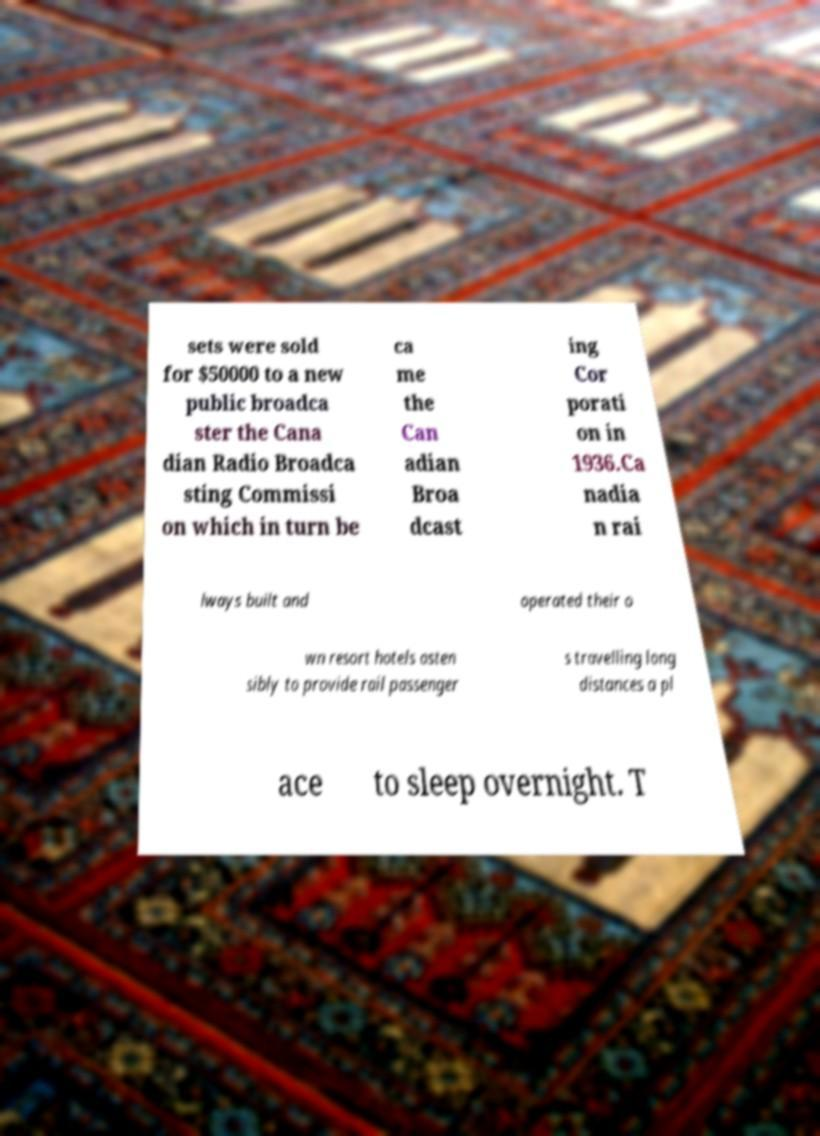Could you assist in decoding the text presented in this image and type it out clearly? sets were sold for $50000 to a new public broadca ster the Cana dian Radio Broadca sting Commissi on which in turn be ca me the Can adian Broa dcast ing Cor porati on in 1936.Ca nadia n rai lways built and operated their o wn resort hotels osten sibly to provide rail passenger s travelling long distances a pl ace to sleep overnight. T 